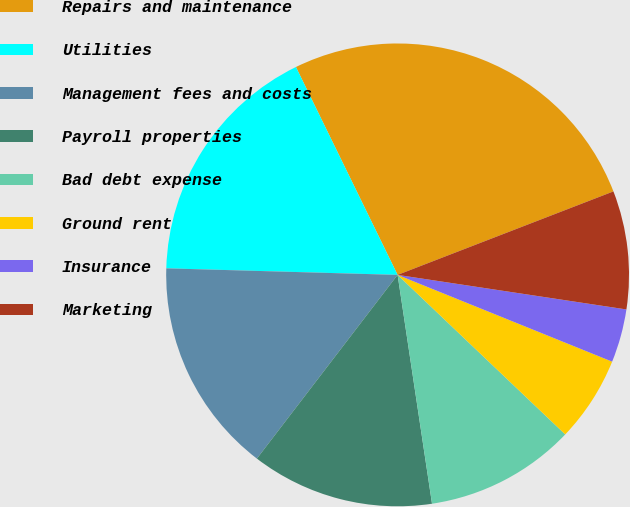Convert chart. <chart><loc_0><loc_0><loc_500><loc_500><pie_chart><fcel>Repairs and maintenance<fcel>Utilities<fcel>Management fees and costs<fcel>Payroll properties<fcel>Bad debt expense<fcel>Ground rent<fcel>Insurance<fcel>Marketing<nl><fcel>26.37%<fcel>17.31%<fcel>15.05%<fcel>12.78%<fcel>10.52%<fcel>5.99%<fcel>3.73%<fcel>8.26%<nl></chart> 